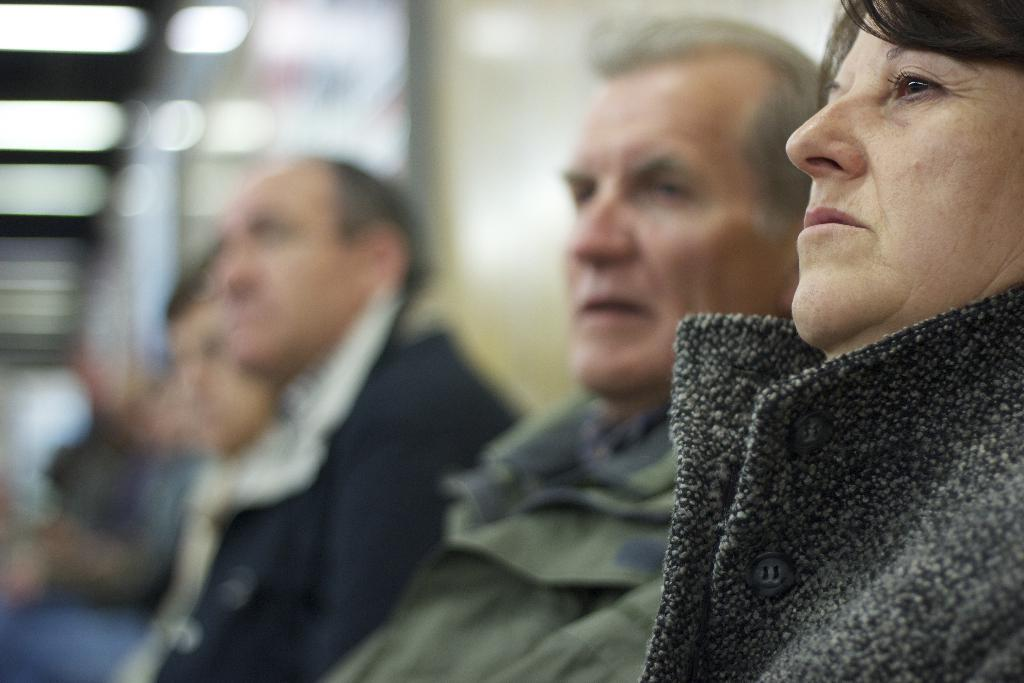What are the people in the image doing? The people in the image are sitting. Can you describe the background of the image? The background of the image is blurred. What type of disgusting food can be seen being pulled by its tail in the image? There is no food or any object being pulled by its tail present in the image. 